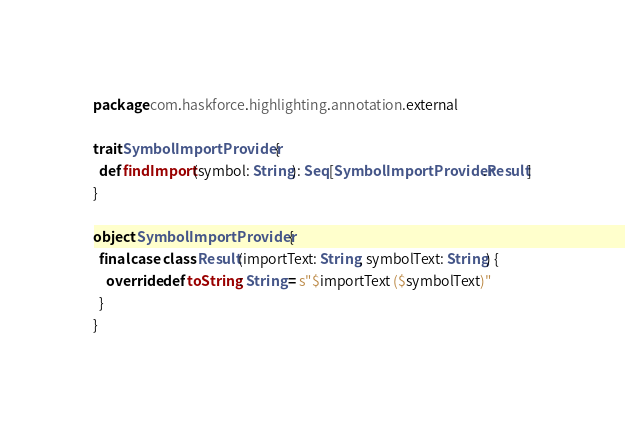<code> <loc_0><loc_0><loc_500><loc_500><_Scala_>package com.haskforce.highlighting.annotation.external

trait SymbolImportProvider {
  def findImport(symbol: String): Seq[SymbolImportProvider.Result]
}

object SymbolImportProvider {
  final case class Result(importText: String, symbolText: String) {
    override def toString: String = s"$importText ($symbolText)"
  }
}
</code> 